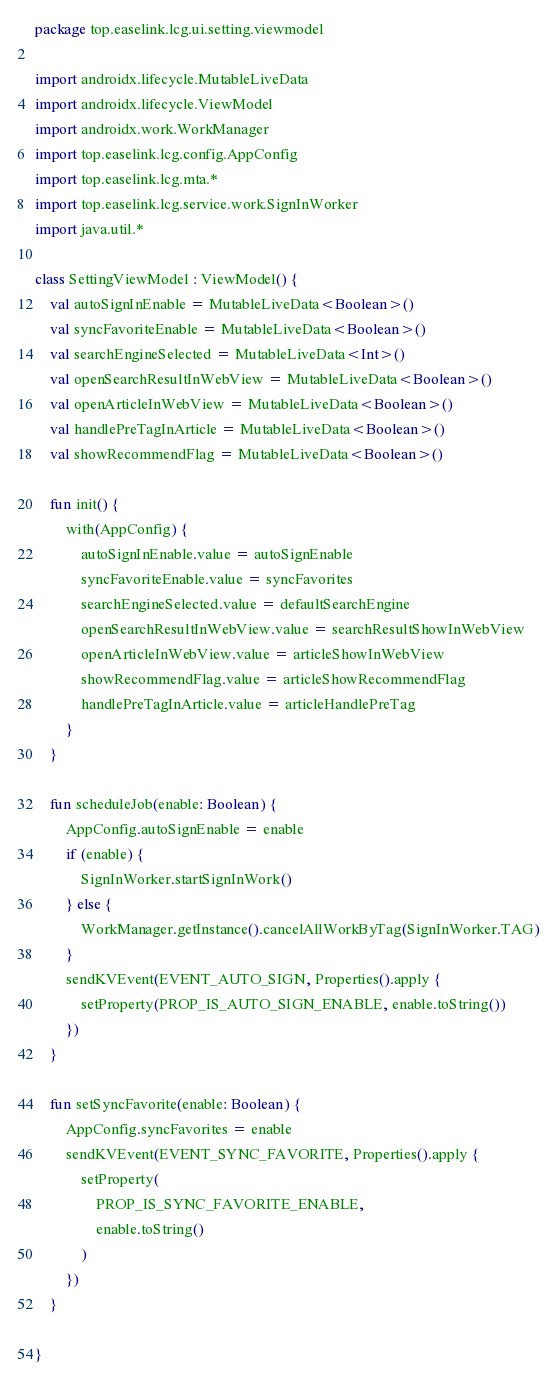<code> <loc_0><loc_0><loc_500><loc_500><_Kotlin_>package top.easelink.lcg.ui.setting.viewmodel

import androidx.lifecycle.MutableLiveData
import androidx.lifecycle.ViewModel
import androidx.work.WorkManager
import top.easelink.lcg.config.AppConfig
import top.easelink.lcg.mta.*
import top.easelink.lcg.service.work.SignInWorker
import java.util.*

class SettingViewModel : ViewModel() {
    val autoSignInEnable = MutableLiveData<Boolean>()
    val syncFavoriteEnable = MutableLiveData<Boolean>()
    val searchEngineSelected = MutableLiveData<Int>()
    val openSearchResultInWebView = MutableLiveData<Boolean>()
    val openArticleInWebView = MutableLiveData<Boolean>()
    val handlePreTagInArticle = MutableLiveData<Boolean>()
    val showRecommendFlag = MutableLiveData<Boolean>()

    fun init() {
        with(AppConfig) {
            autoSignInEnable.value = autoSignEnable
            syncFavoriteEnable.value = syncFavorites
            searchEngineSelected.value = defaultSearchEngine
            openSearchResultInWebView.value = searchResultShowInWebView
            openArticleInWebView.value = articleShowInWebView
            showRecommendFlag.value = articleShowRecommendFlag
            handlePreTagInArticle.value = articleHandlePreTag
        }
    }

    fun scheduleJob(enable: Boolean) {
        AppConfig.autoSignEnable = enable
        if (enable) {
            SignInWorker.startSignInWork()
        } else {
            WorkManager.getInstance().cancelAllWorkByTag(SignInWorker.TAG)
        }
        sendKVEvent(EVENT_AUTO_SIGN, Properties().apply {
            setProperty(PROP_IS_AUTO_SIGN_ENABLE, enable.toString())
        })
    }

    fun setSyncFavorite(enable: Boolean) {
        AppConfig.syncFavorites = enable
        sendKVEvent(EVENT_SYNC_FAVORITE, Properties().apply {
            setProperty(
                PROP_IS_SYNC_FAVORITE_ENABLE,
                enable.toString()
            )
        })
    }

}</code> 